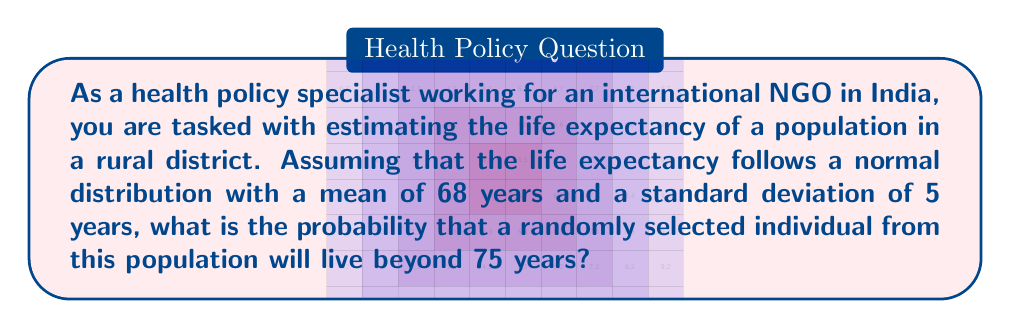Show me your answer to this math problem. To solve this problem, we need to use the properties of the normal distribution and the concept of z-scores. Let's approach this step-by-step:

1. Given information:
   - Life expectancy follows a normal distribution
   - Mean (μ) = 68 years
   - Standard deviation (σ) = 5 years
   - We want to find P(X > 75), where X is the life expectancy

2. Calculate the z-score for 75 years:
   $$ z = \frac{x - \mu}{\sigma} = \frac{75 - 68}{5} = 1.4 $$

3. The probability we're looking for is the area under the normal curve to the right of z = 1.4. This is equal to 1 minus the area to the left of z = 1.4.

4. Using a standard normal distribution table or a calculator, we can find that the area to the left of z = 1.4 is approximately 0.9192.

5. Therefore, the probability of living beyond 75 years is:
   $$ P(X > 75) = 1 - P(X \leq 75) = 1 - 0.9192 = 0.0808 $$

6. Convert to a percentage:
   $$ 0.0808 \times 100\% = 8.08\% $$

This means that approximately 8.08% of the population in this rural district is expected to live beyond 75 years.
Answer: 8.08% 